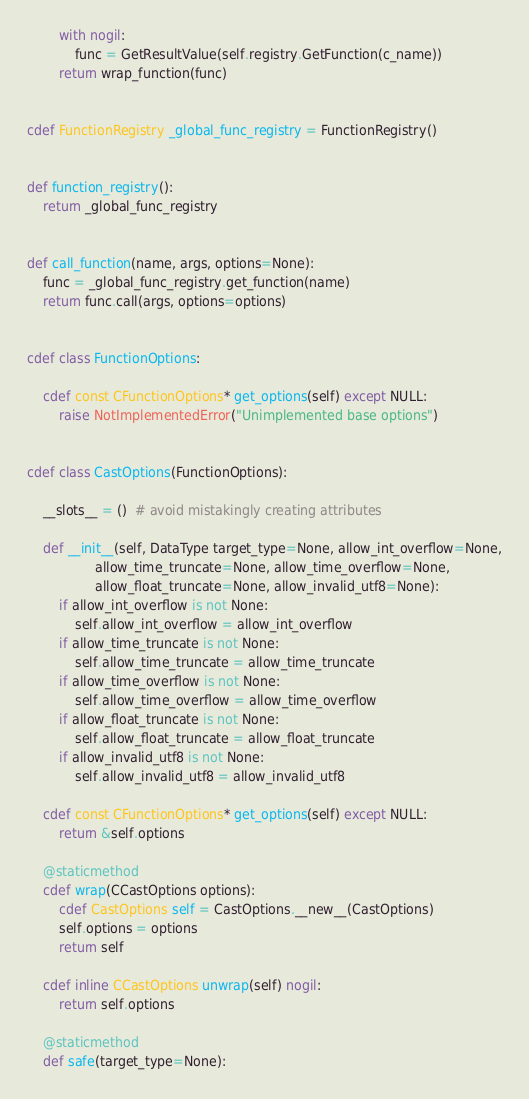<code> <loc_0><loc_0><loc_500><loc_500><_Cython_>        with nogil:
            func = GetResultValue(self.registry.GetFunction(c_name))
        return wrap_function(func)


cdef FunctionRegistry _global_func_registry = FunctionRegistry()


def function_registry():
    return _global_func_registry


def call_function(name, args, options=None):
    func = _global_func_registry.get_function(name)
    return func.call(args, options=options)


cdef class FunctionOptions:

    cdef const CFunctionOptions* get_options(self) except NULL:
        raise NotImplementedError("Unimplemented base options")


cdef class CastOptions(FunctionOptions):

    __slots__ = ()  # avoid mistakingly creating attributes

    def __init__(self, DataType target_type=None, allow_int_overflow=None,
                 allow_time_truncate=None, allow_time_overflow=None,
                 allow_float_truncate=None, allow_invalid_utf8=None):
        if allow_int_overflow is not None:
            self.allow_int_overflow = allow_int_overflow
        if allow_time_truncate is not None:
            self.allow_time_truncate = allow_time_truncate
        if allow_time_overflow is not None:
            self.allow_time_overflow = allow_time_overflow
        if allow_float_truncate is not None:
            self.allow_float_truncate = allow_float_truncate
        if allow_invalid_utf8 is not None:
            self.allow_invalid_utf8 = allow_invalid_utf8

    cdef const CFunctionOptions* get_options(self) except NULL:
        return &self.options

    @staticmethod
    cdef wrap(CCastOptions options):
        cdef CastOptions self = CastOptions.__new__(CastOptions)
        self.options = options
        return self

    cdef inline CCastOptions unwrap(self) nogil:
        return self.options

    @staticmethod
    def safe(target_type=None):</code> 